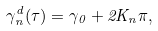Convert formula to latex. <formula><loc_0><loc_0><loc_500><loc_500>\gamma _ { n } ^ { d } ( \tau ) = \gamma _ { 0 } + 2 K _ { n } \pi ,</formula> 